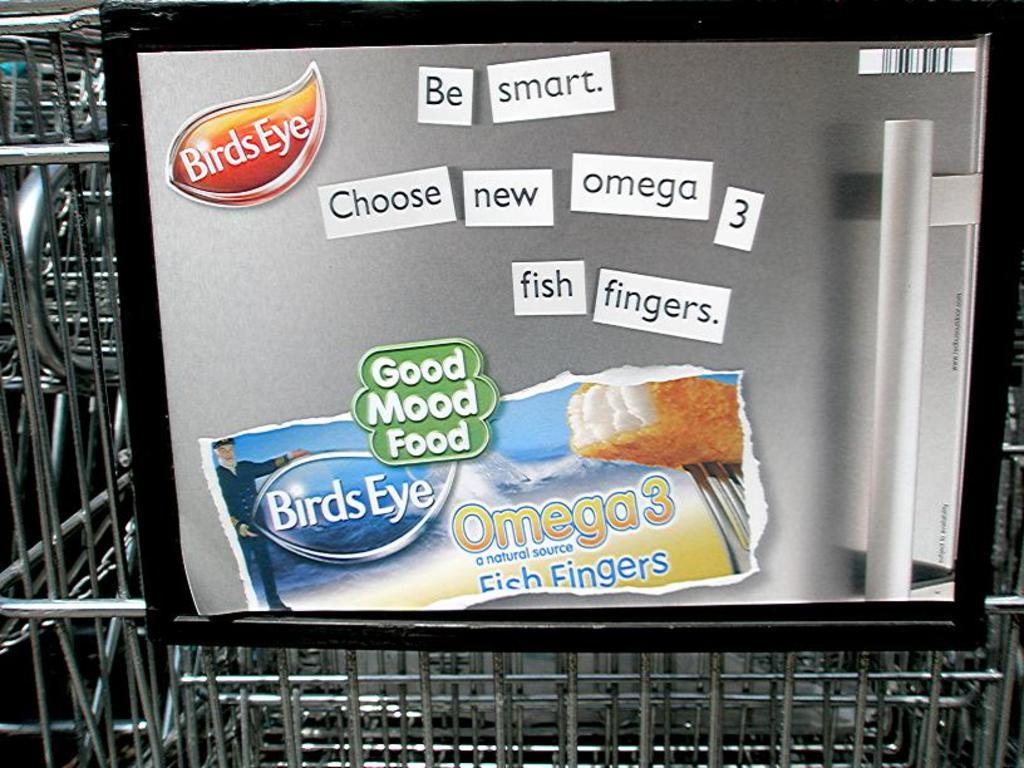What is the sign telling us to choose?
Give a very brief answer. New omega 3 fish fingers. What type of fish is advertised?
Keep it short and to the point. Fish fingers. 